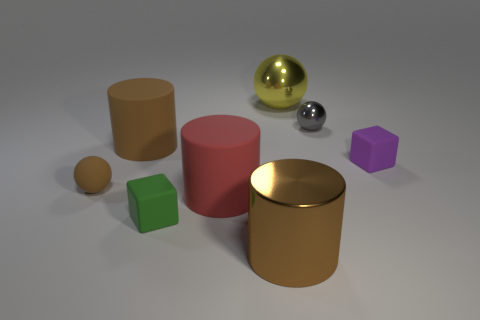Add 2 matte balls. How many objects exist? 10 Subtract all spheres. How many objects are left? 5 Add 1 small brown objects. How many small brown objects exist? 2 Subtract 0 blue cylinders. How many objects are left? 8 Subtract all tiny brown balls. Subtract all big yellow objects. How many objects are left? 6 Add 8 large red cylinders. How many large red cylinders are left? 9 